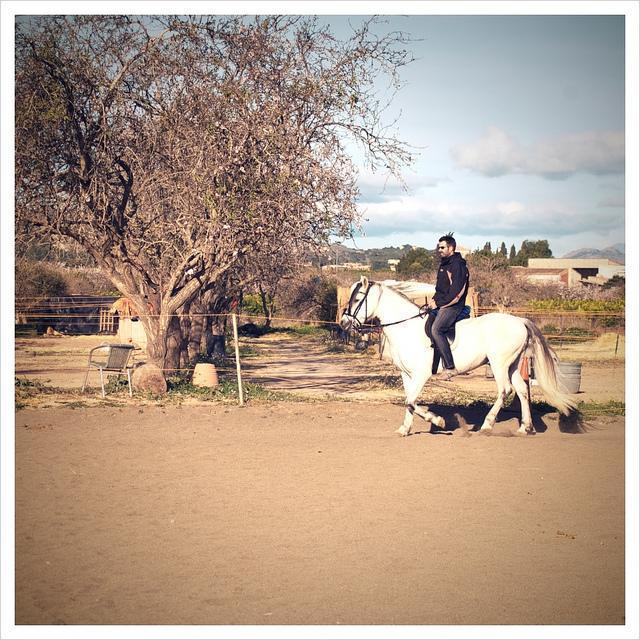How many horses in the photo?
Give a very brief answer. 1. 